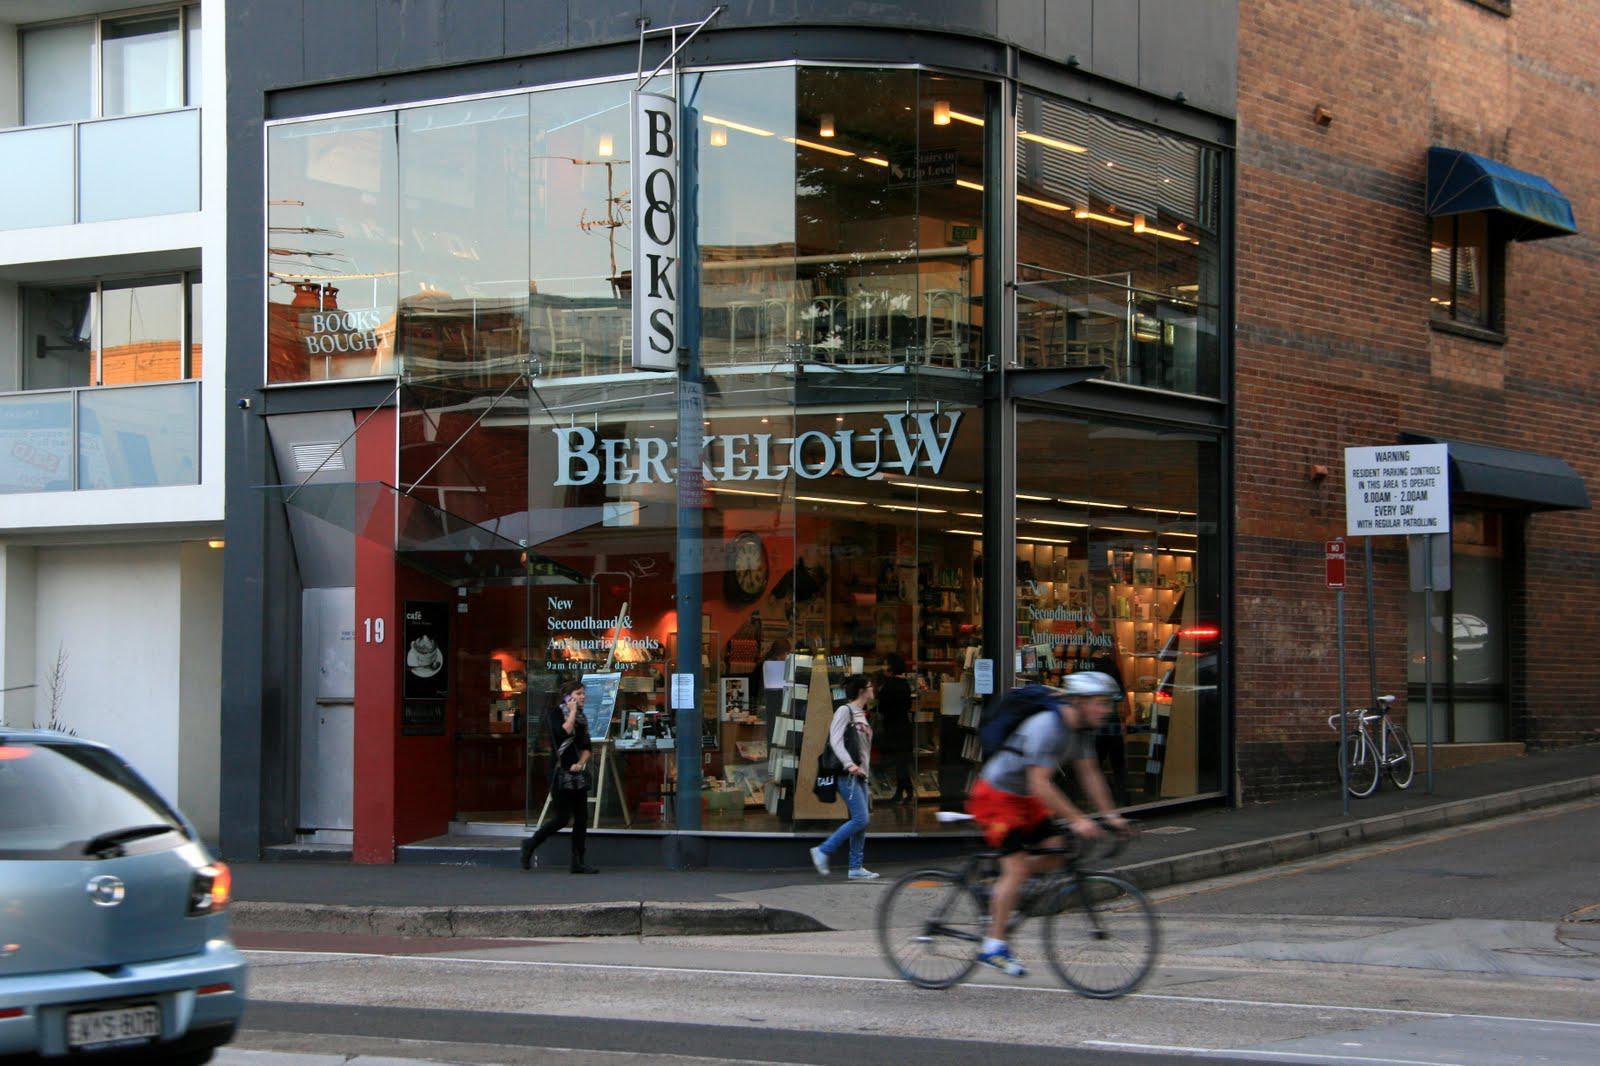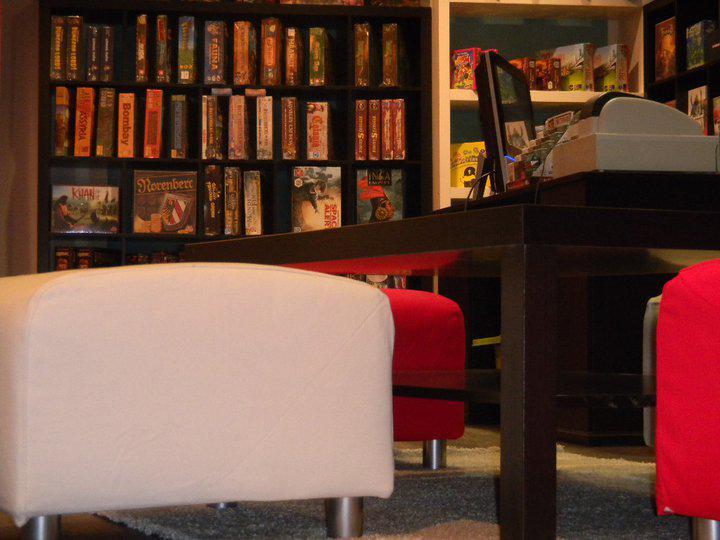The first image is the image on the left, the second image is the image on the right. Considering the images on both sides, is "The bookshop in the right image has an informational fold out sign out front." valid? Answer yes or no. No. The first image is the image on the left, the second image is the image on the right. Examine the images to the left and right. Is the description "In at least one image there is a single book display in the window with at least one neon sign hanging about the books." accurate? Answer yes or no. No. 